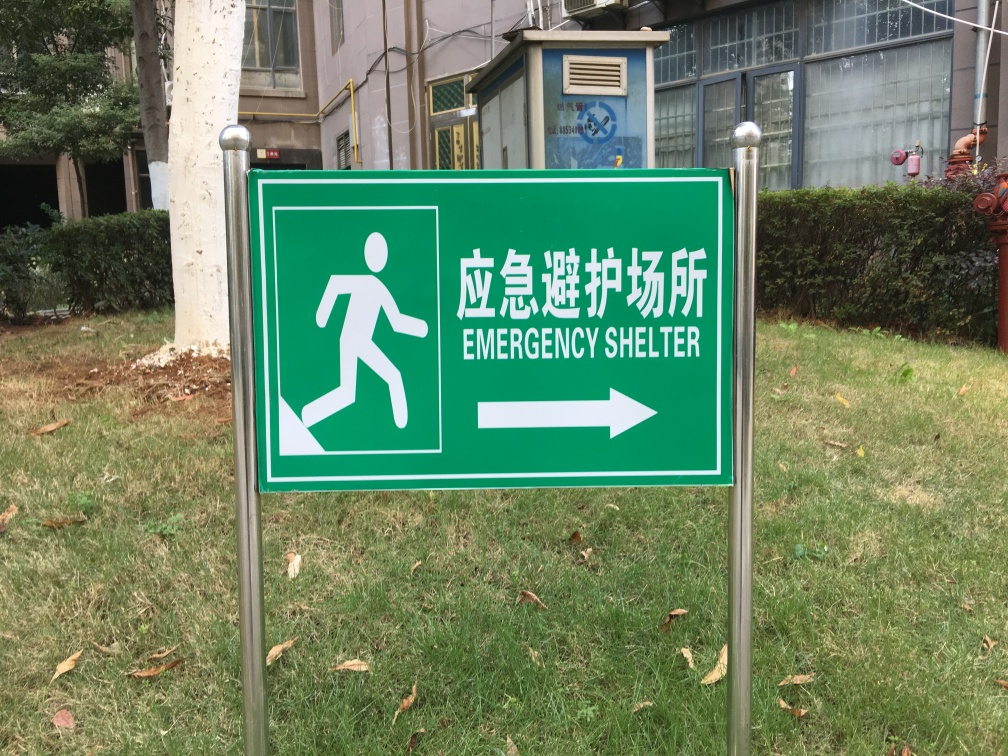Are there any indications about the location where this photo was taken? Based on the bilingual text on the sign, using both English and Chinese, it's likely that this photo was taken in a Chinese-speaking region or country that also uses English for public signage, indicating a consideration for international visitors or a diverse local population. 